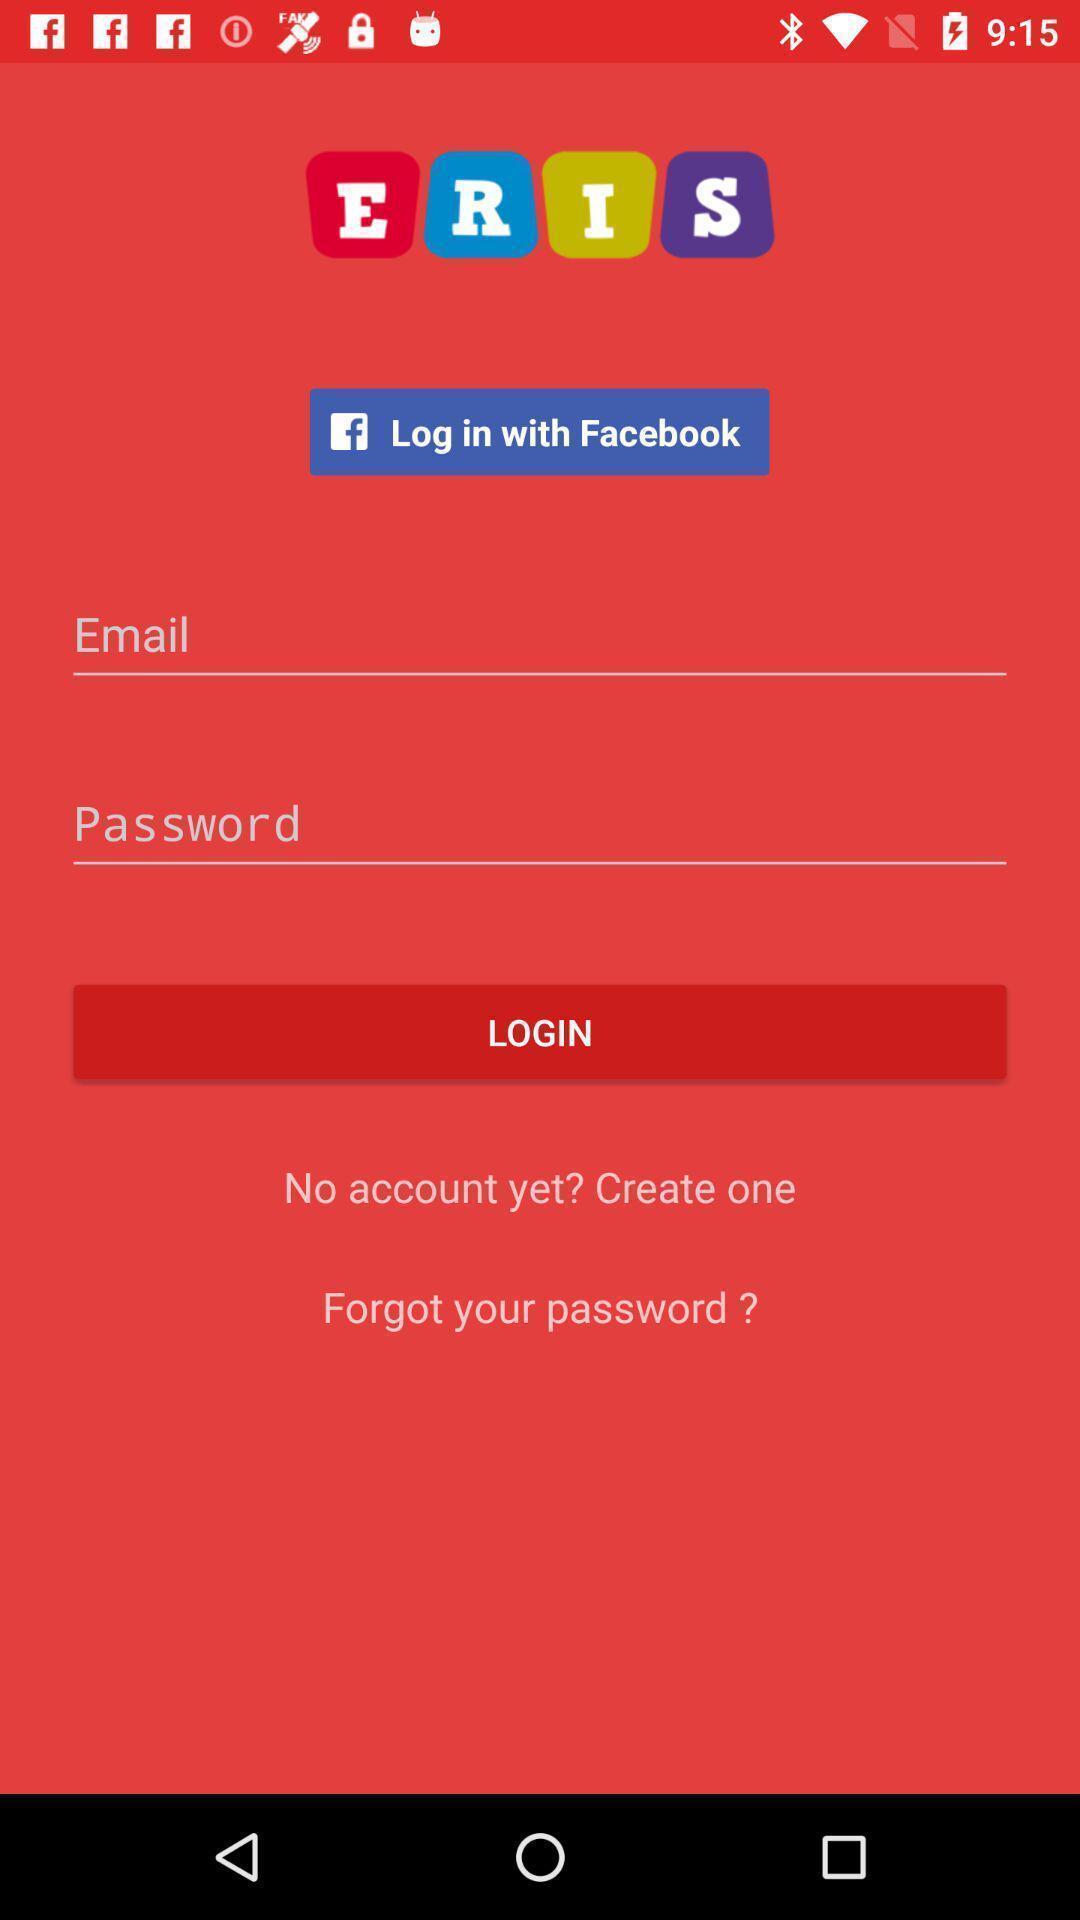Give me a summary of this screen capture. Welcome to the login page. 